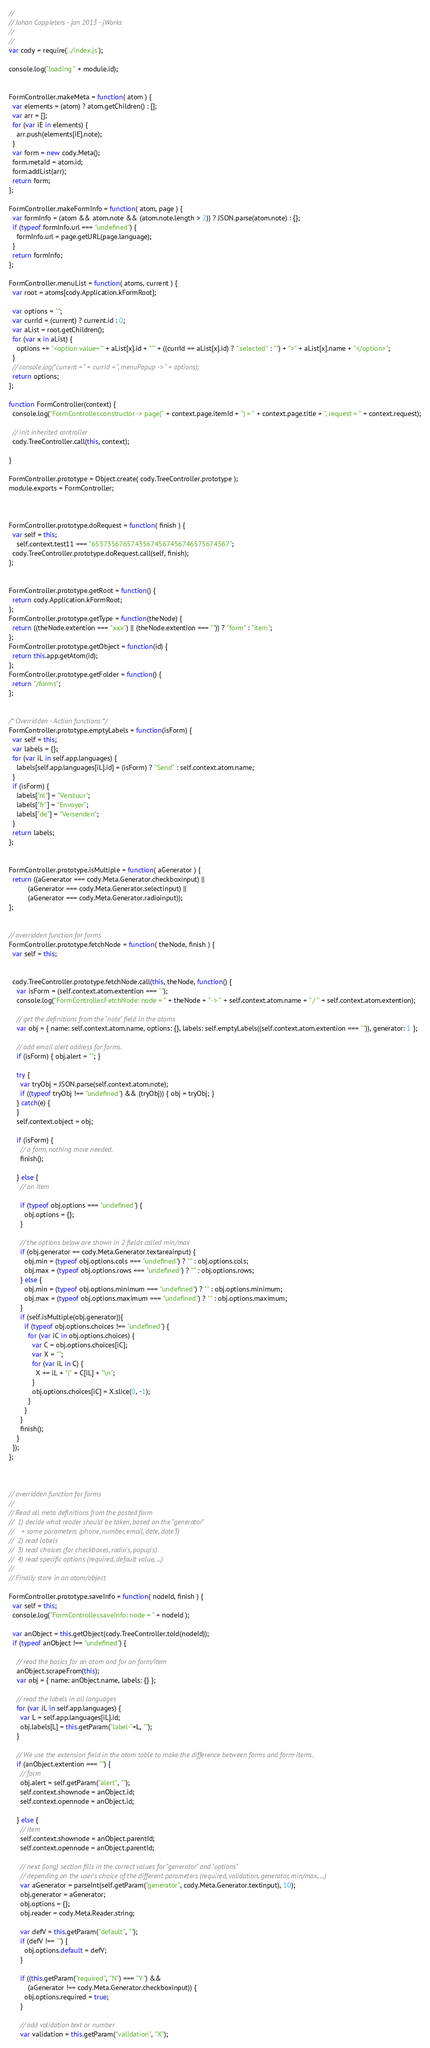<code> <loc_0><loc_0><loc_500><loc_500><_JavaScript_>//
// Johan Coppieters - jan 2013 - jWorks
//
//
var cody = require('../index.js');

console.log("loading " + module.id);


FormController.makeMeta = function( atom ) {
  var elements = (atom) ? atom.getChildren() : [];
  var arr = [];
  for (var iE in elements) {
    arr.push(elements[iE].note);
  }
  var form = new cody.Meta();
  form.metaId = atom.id;
  form.addList(arr);
  return form;
};

FormController.makeFormInfo = function( atom, page ) {
  var formInfo = (atom && atom.note && (atom.note.length > 2)) ? JSON.parse(atom.note) : {};
  if (typeof formInfo.url === "undefined") {
    formInfo.url = page.getURL(page.language);
  }
  return formInfo;
};

FormController.menuList = function( atoms, current ) {
  var root = atoms[cody.Application.kFormRoot];

  var options = "";
  var currId = (current) ? current.id : 0;
  var aList = root.getChildren();
  for (var x in aList) {
    options += "<option value='" + aList[x].id + "'" + ((currId == aList[x].id) ? " selected" : "") + ">" + aList[x].name + "</option>";
  }
  // console.log("current = " + currId + ", menuPopup -> " + options);
  return options;
};

function FormController(context) {
  console.log("FormController.constructor -> page(" + context.page.itemId + ") = " + context.page.title + ", request = " + context.request);
  
  // init inherited controller
  cody.TreeController.call(this, context);
  
}

FormController.prototype = Object.create( cody.TreeController.prototype );
module.exports = FormController;



FormController.prototype.doRequest = function( finish ) {
  var self = this;
	self.context.test11 === "65373567657435674567456746575674567";
  cody.TreeController.prototype.doRequest.call(self, finish);
};


FormController.prototype.getRoot = function() {
  return cody.Application.kFormRoot;
};
FormController.prototype.getType = function(theNode) { 
  return ((theNode.extention === "xxx") || (theNode.extention === "")) ? "form" : "item";
};
FormController.prototype.getObject = function(id) {
  return this.app.getAtom(id);
};
FormController.prototype.getFolder = function() { 
  return "/forms";
};


/* Overridden - Action functions */
FormController.prototype.emptyLabels = function(isForm) {
  var self = this;
  var labels = {};
  for (var iL in self.app.languages) {
    labels[self.app.languages[iL].id] = (isForm) ? "Send" : self.context.atom.name;
  }
  if (isForm) {
    labels["nl"] = "Verstuur";
    labels["fr"] = "Envoyer";
    labels["de"] = "Versenden";
  }
  return labels;
};


FormController.prototype.isMultiple = function( aGenerator ) {
  return ((aGenerator === cody.Meta.Generator.checkboxinput) ||
          (aGenerator === cody.Meta.Generator.selectinput) ||
          (aGenerator === cody.Meta.Generator.radioinput));
};


// overridden function for forms
FormController.prototype.fetchNode = function( theNode, finish ) {
  var self = this;


  cody.TreeController.prototype.fetchNode.call(this, theNode, function() {
    var isForm = (self.context.atom.extention === "");
    console.log("FormController.FetchNode: node = " + theNode + " -> " + self.context.atom.name + " / " + self.context.atom.extention);

    // get the definitions from the "note" field in the atoms
    var obj = { name: self.context.atom.name, options: {}, labels: self.emptyLabels((self.context.atom.extention === "")), generator: 1 };

    // add email alert address for forms.
    if (isForm) { obj.alert = ""; }

    try {
      var tryObj = JSON.parse(self.context.atom.note);
      if ((typeof tryObj !== "undefined") && (tryObj)) { obj = tryObj; }
    } catch(e) {
    }
    self.context.object = obj;

    if (isForm) {
      // a form, nothing more needed.
      finish();

    } else {
      // an item

      if (typeof obj.options === "undefined") {
        obj.options = {};
      }

      // the options below are shown in 2 fields called min/max
      if (obj.generator == cody.Meta.Generator.textareainput) {
        obj.min = (typeof obj.options.cols === "undefined") ? "" : obj.options.cols;
        obj.max = (typeof obj.options.rows === "undefined") ? "" : obj.options.rows;
      } else {
        obj.min = (typeof obj.options.minimum === "undefined") ? "" : obj.options.minimum;
        obj.max = (typeof obj.options.maximum === "undefined") ? "" : obj.options.maximum;
      }
      if (self.isMultiple(obj.generator)){
        if (typeof obj.options.choices !== "undefined") {
          for (var iC in obj.options.choices) {
            var C = obj.options.choices[iC];
            var X = "";
            for (var iL in C) {
              X += iL + "|" + C[iL] + "\n";
            }
            obj.options.choices[iC] = X.slice(0, -1);
          }
        }
      }
      finish();
    }
  });
};



// overridden function for forms
//
// Read all meta definitions from the posted form
//  1) decide what reader should be taken, based on the "generator"
//    + some parameters (phone, number, email, date, date3)
//  2) read labels
//  3) read choices (for checkboxes, radio's, popup's)
//  4) read specific options (required, default value, ...)
//
// Finally store in an atom/object

FormController.prototype.saveInfo = function( nodeId, finish ) {
  var self = this;
  console.log("FormController.saveInfo: node = " + nodeId );

  var anObject = this.getObject(cody.TreeController.toId(nodeId));
  if (typeof anObject !== "undefined") {

    // read the basics for an atom and for an form/item
    anObject.scrapeFrom(this);
    var obj = { name: anObject.name, labels: {} };

    // read the labels in all languages
    for (var iL in self.app.languages) {
      var L = self.app.languages[iL].id;
      obj.labels[L] = this.getParam("label-"+L, "");
    }

    // We use the extension field in the atom table to make the difference between forms and form-items.
    if (anObject.extention === "") {
      // form
      obj.alert = self.getParam("alert", "");
      self.context.shownode = anObject.id;
      self.context.opennode = anObject.id;

    } else {
      // item
      self.context.shownode = anObject.parentId;
      self.context.opennode = anObject.parentId;

      // next (long) section fills in the correct values for "generator" and "options"
      // depending on the user's choice of the different parameters (required, validation, generator, min/max, ...)
      var aGenerator = parseInt(self.getParam("generator", cody.Meta.Generator.textinput), 10);
      obj.generator = aGenerator;
      obj.options = {};
      obj.reader = cody.Meta.Reader.string;

      var defV = this.getParam("default", "");
      if (defV !== "") {
        obj.options.default = defV;
      }

      if ((this.getParam("required", "N") === "Y") &&
          (aGenerator !== cody.Meta.Generator.checkboxinput)) {
        obj.options.required = true;
      }

      // add validation text or number
      var validation = this.getParam("validation", "X");</code> 